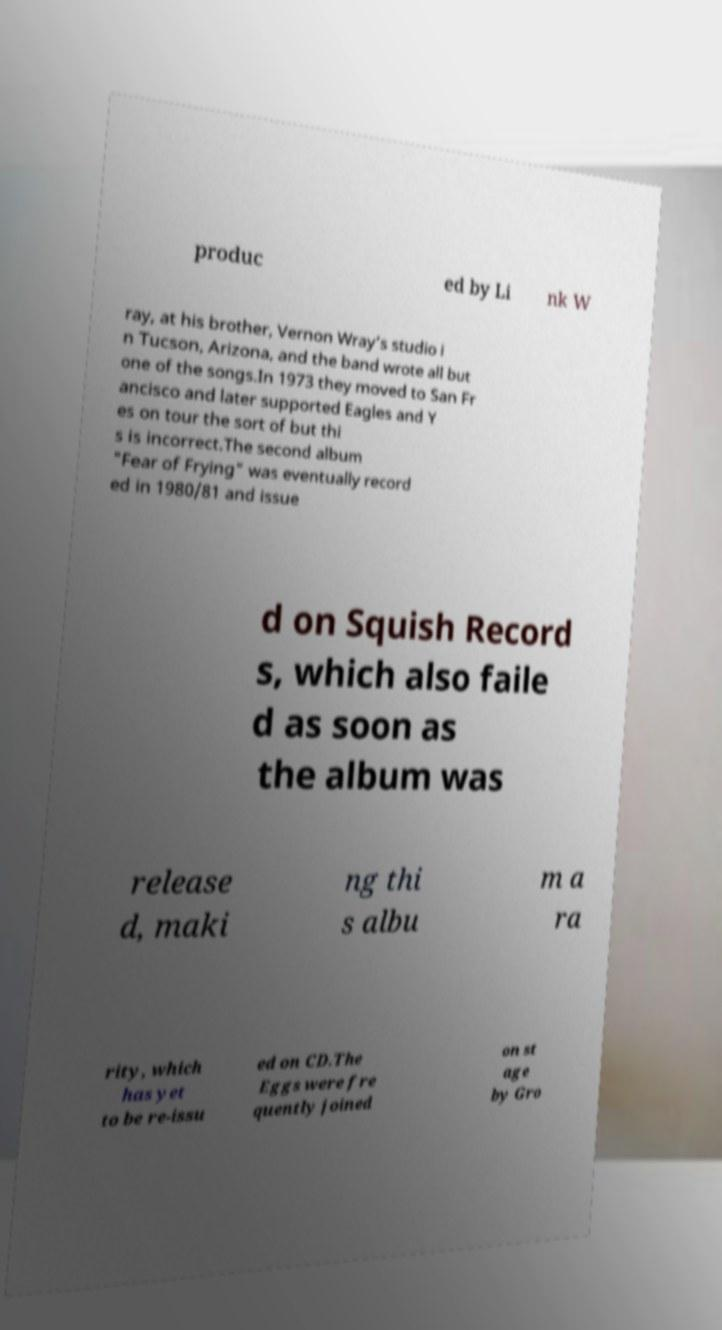Could you extract and type out the text from this image? produc ed by Li nk W ray, at his brother, Vernon Wray’s studio i n Tucson, Arizona, and the band wrote all but one of the songs.In 1973 they moved to San Fr ancisco and later supported Eagles and Y es on tour the sort of but thi s is incorrect.The second album "Fear of Frying" was eventually record ed in 1980/81 and issue d on Squish Record s, which also faile d as soon as the album was release d, maki ng thi s albu m a ra rity, which has yet to be re-issu ed on CD.The Eggs were fre quently joined on st age by Gro 